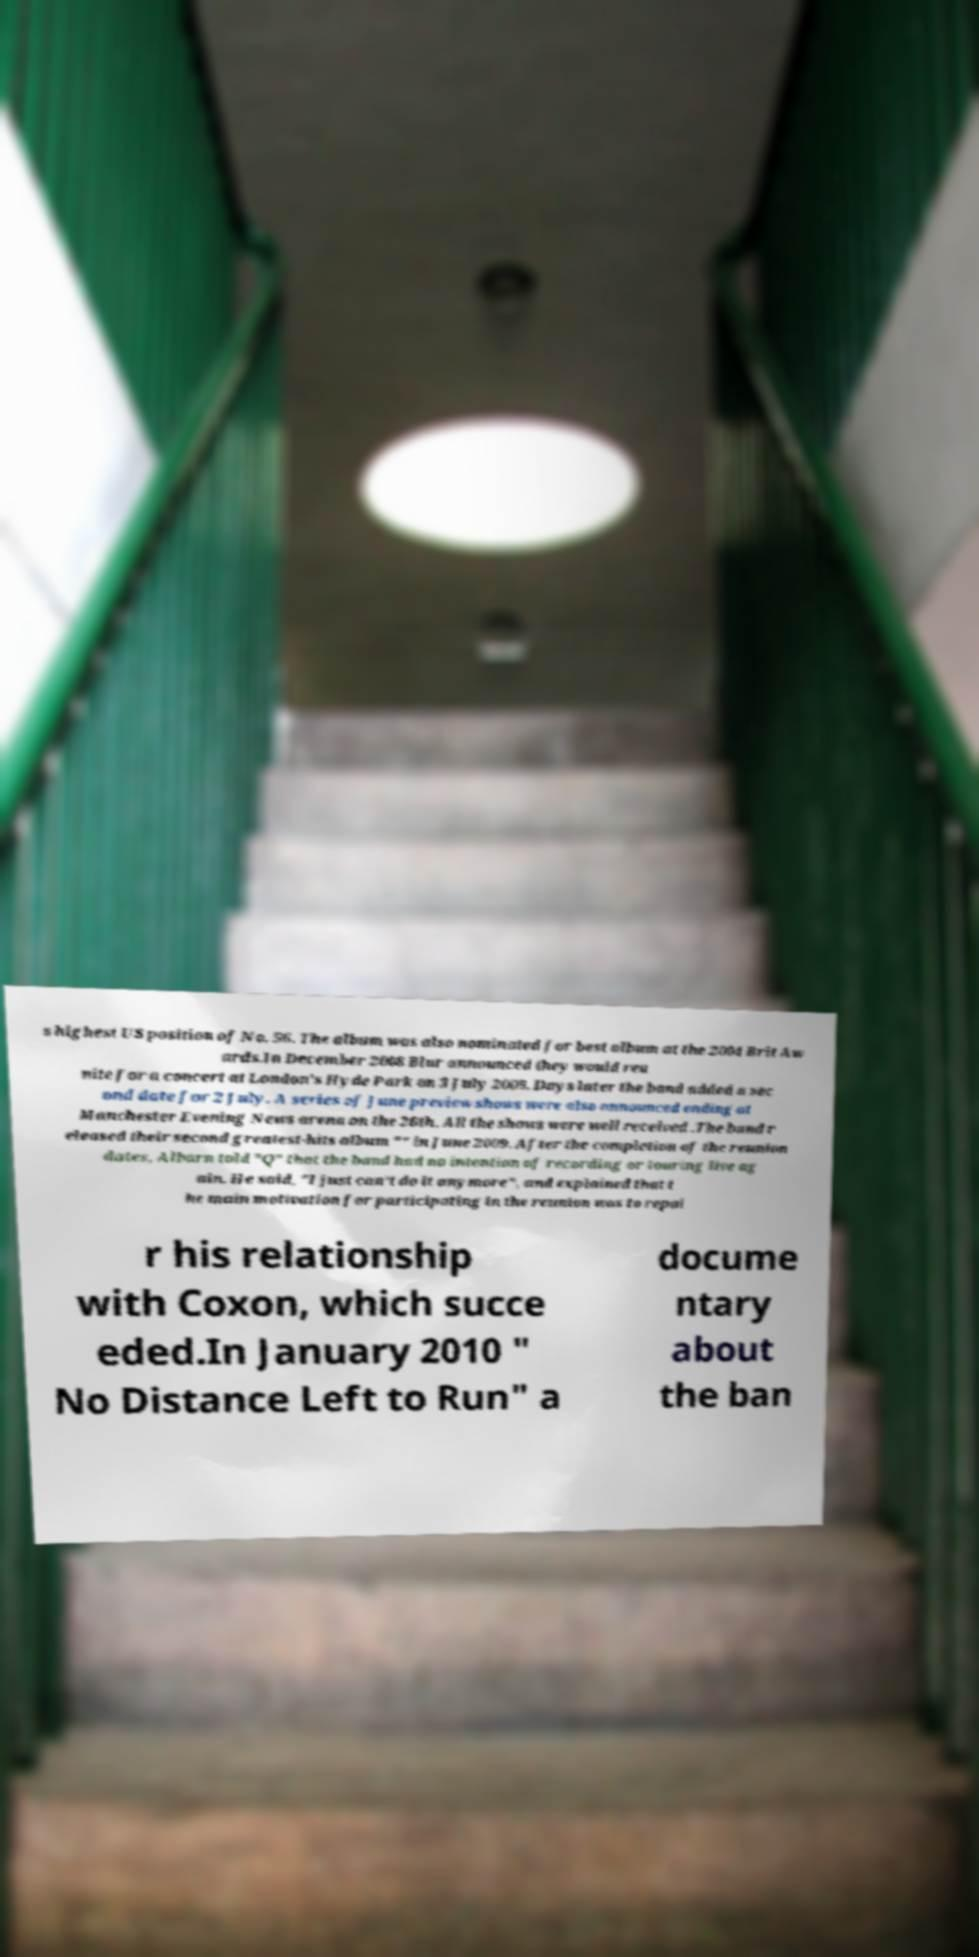There's text embedded in this image that I need extracted. Can you transcribe it verbatim? s highest US position of No. 56. The album was also nominated for best album at the 2004 Brit Aw ards.In December 2008 Blur announced they would reu nite for a concert at London's Hyde Park on 3 July 2009. Days later the band added a sec ond date for 2 July. A series of June preview shows were also announced ending at Manchester Evening News arena on the 26th. All the shows were well received .The band r eleased their second greatest-hits album "" in June 2009. After the completion of the reunion dates, Albarn told "Q" that the band had no intention of recording or touring live ag ain. He said, "I just can't do it anymore", and explained that t he main motivation for participating in the reunion was to repai r his relationship with Coxon, which succe eded.In January 2010 " No Distance Left to Run" a docume ntary about the ban 